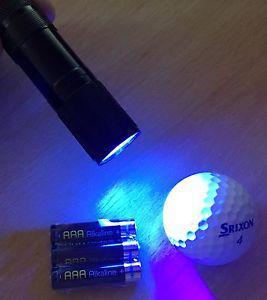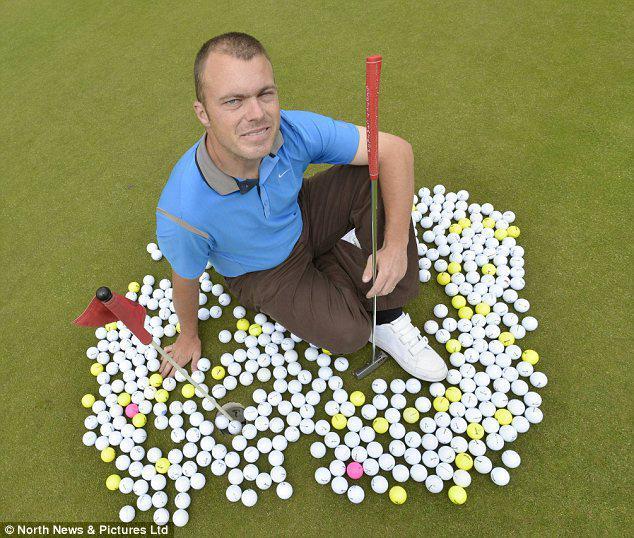The first image is the image on the left, the second image is the image on the right. For the images shown, is this caption "There are two cardboard boxes in the image on the right." true? Answer yes or no. No. The first image is the image on the left, the second image is the image on the right. For the images displayed, is the sentence "One image shows a golf ball bucket with at least two bright orange balls." factually correct? Answer yes or no. No. 